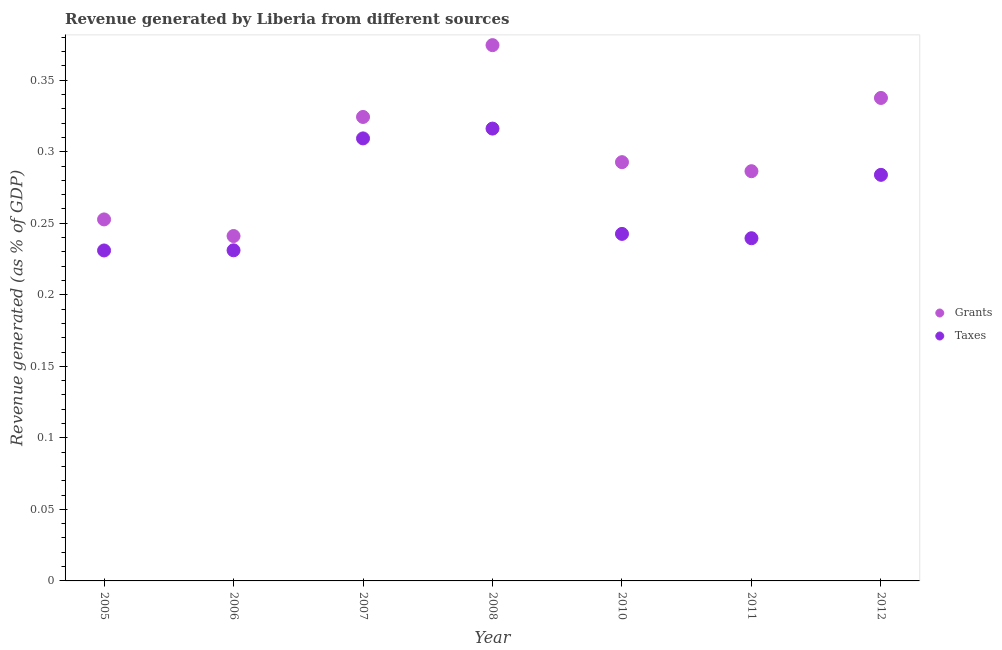What is the revenue generated by grants in 2006?
Give a very brief answer. 0.24. Across all years, what is the maximum revenue generated by grants?
Give a very brief answer. 0.37. Across all years, what is the minimum revenue generated by taxes?
Give a very brief answer. 0.23. In which year was the revenue generated by taxes maximum?
Your response must be concise. 2008. What is the total revenue generated by taxes in the graph?
Give a very brief answer. 1.85. What is the difference between the revenue generated by taxes in 2008 and that in 2011?
Make the answer very short. 0.08. What is the difference between the revenue generated by grants in 2005 and the revenue generated by taxes in 2008?
Offer a very short reply. -0.06. What is the average revenue generated by taxes per year?
Your answer should be compact. 0.26. In the year 2006, what is the difference between the revenue generated by taxes and revenue generated by grants?
Provide a succinct answer. -0.01. What is the ratio of the revenue generated by taxes in 2011 to that in 2012?
Your response must be concise. 0.84. Is the revenue generated by grants in 2005 less than that in 2010?
Keep it short and to the point. Yes. What is the difference between the highest and the second highest revenue generated by grants?
Your answer should be compact. 0.04. What is the difference between the highest and the lowest revenue generated by grants?
Offer a very short reply. 0.13. In how many years, is the revenue generated by grants greater than the average revenue generated by grants taken over all years?
Provide a short and direct response. 3. Does the revenue generated by taxes monotonically increase over the years?
Provide a short and direct response. No. Is the revenue generated by taxes strictly greater than the revenue generated by grants over the years?
Your answer should be very brief. No. Is the revenue generated by taxes strictly less than the revenue generated by grants over the years?
Offer a very short reply. Yes. How many dotlines are there?
Provide a succinct answer. 2. How many years are there in the graph?
Offer a terse response. 7. What is the difference between two consecutive major ticks on the Y-axis?
Your answer should be compact. 0.05. How are the legend labels stacked?
Keep it short and to the point. Vertical. What is the title of the graph?
Ensure brevity in your answer.  Revenue generated by Liberia from different sources. Does "Resident" appear as one of the legend labels in the graph?
Provide a short and direct response. No. What is the label or title of the Y-axis?
Offer a terse response. Revenue generated (as % of GDP). What is the Revenue generated (as % of GDP) in Grants in 2005?
Provide a succinct answer. 0.25. What is the Revenue generated (as % of GDP) in Taxes in 2005?
Ensure brevity in your answer.  0.23. What is the Revenue generated (as % of GDP) of Grants in 2006?
Your answer should be compact. 0.24. What is the Revenue generated (as % of GDP) in Taxes in 2006?
Ensure brevity in your answer.  0.23. What is the Revenue generated (as % of GDP) of Grants in 2007?
Offer a terse response. 0.32. What is the Revenue generated (as % of GDP) in Taxes in 2007?
Provide a succinct answer. 0.31. What is the Revenue generated (as % of GDP) of Grants in 2008?
Offer a terse response. 0.37. What is the Revenue generated (as % of GDP) of Taxes in 2008?
Provide a short and direct response. 0.32. What is the Revenue generated (as % of GDP) of Grants in 2010?
Make the answer very short. 0.29. What is the Revenue generated (as % of GDP) of Taxes in 2010?
Make the answer very short. 0.24. What is the Revenue generated (as % of GDP) of Grants in 2011?
Provide a short and direct response. 0.29. What is the Revenue generated (as % of GDP) in Taxes in 2011?
Your answer should be very brief. 0.24. What is the Revenue generated (as % of GDP) of Grants in 2012?
Offer a terse response. 0.34. What is the Revenue generated (as % of GDP) in Taxes in 2012?
Your answer should be very brief. 0.28. Across all years, what is the maximum Revenue generated (as % of GDP) in Grants?
Offer a terse response. 0.37. Across all years, what is the maximum Revenue generated (as % of GDP) of Taxes?
Your answer should be compact. 0.32. Across all years, what is the minimum Revenue generated (as % of GDP) of Grants?
Offer a terse response. 0.24. Across all years, what is the minimum Revenue generated (as % of GDP) in Taxes?
Offer a terse response. 0.23. What is the total Revenue generated (as % of GDP) in Grants in the graph?
Provide a succinct answer. 2.11. What is the total Revenue generated (as % of GDP) of Taxes in the graph?
Your response must be concise. 1.85. What is the difference between the Revenue generated (as % of GDP) of Grants in 2005 and that in 2006?
Offer a terse response. 0.01. What is the difference between the Revenue generated (as % of GDP) of Taxes in 2005 and that in 2006?
Make the answer very short. -0. What is the difference between the Revenue generated (as % of GDP) in Grants in 2005 and that in 2007?
Keep it short and to the point. -0.07. What is the difference between the Revenue generated (as % of GDP) of Taxes in 2005 and that in 2007?
Provide a succinct answer. -0.08. What is the difference between the Revenue generated (as % of GDP) in Grants in 2005 and that in 2008?
Ensure brevity in your answer.  -0.12. What is the difference between the Revenue generated (as % of GDP) in Taxes in 2005 and that in 2008?
Provide a succinct answer. -0.09. What is the difference between the Revenue generated (as % of GDP) in Grants in 2005 and that in 2010?
Make the answer very short. -0.04. What is the difference between the Revenue generated (as % of GDP) in Taxes in 2005 and that in 2010?
Your answer should be very brief. -0.01. What is the difference between the Revenue generated (as % of GDP) in Grants in 2005 and that in 2011?
Your answer should be compact. -0.03. What is the difference between the Revenue generated (as % of GDP) of Taxes in 2005 and that in 2011?
Make the answer very short. -0.01. What is the difference between the Revenue generated (as % of GDP) of Grants in 2005 and that in 2012?
Keep it short and to the point. -0.08. What is the difference between the Revenue generated (as % of GDP) of Taxes in 2005 and that in 2012?
Make the answer very short. -0.05. What is the difference between the Revenue generated (as % of GDP) of Grants in 2006 and that in 2007?
Provide a short and direct response. -0.08. What is the difference between the Revenue generated (as % of GDP) in Taxes in 2006 and that in 2007?
Offer a terse response. -0.08. What is the difference between the Revenue generated (as % of GDP) in Grants in 2006 and that in 2008?
Ensure brevity in your answer.  -0.13. What is the difference between the Revenue generated (as % of GDP) in Taxes in 2006 and that in 2008?
Make the answer very short. -0.09. What is the difference between the Revenue generated (as % of GDP) in Grants in 2006 and that in 2010?
Your response must be concise. -0.05. What is the difference between the Revenue generated (as % of GDP) of Taxes in 2006 and that in 2010?
Your answer should be compact. -0.01. What is the difference between the Revenue generated (as % of GDP) of Grants in 2006 and that in 2011?
Give a very brief answer. -0.05. What is the difference between the Revenue generated (as % of GDP) in Taxes in 2006 and that in 2011?
Provide a succinct answer. -0.01. What is the difference between the Revenue generated (as % of GDP) in Grants in 2006 and that in 2012?
Your answer should be very brief. -0.1. What is the difference between the Revenue generated (as % of GDP) in Taxes in 2006 and that in 2012?
Give a very brief answer. -0.05. What is the difference between the Revenue generated (as % of GDP) of Grants in 2007 and that in 2008?
Offer a very short reply. -0.05. What is the difference between the Revenue generated (as % of GDP) in Taxes in 2007 and that in 2008?
Give a very brief answer. -0.01. What is the difference between the Revenue generated (as % of GDP) of Grants in 2007 and that in 2010?
Keep it short and to the point. 0.03. What is the difference between the Revenue generated (as % of GDP) of Taxes in 2007 and that in 2010?
Offer a terse response. 0.07. What is the difference between the Revenue generated (as % of GDP) in Grants in 2007 and that in 2011?
Your answer should be compact. 0.04. What is the difference between the Revenue generated (as % of GDP) of Taxes in 2007 and that in 2011?
Provide a succinct answer. 0.07. What is the difference between the Revenue generated (as % of GDP) of Grants in 2007 and that in 2012?
Make the answer very short. -0.01. What is the difference between the Revenue generated (as % of GDP) in Taxes in 2007 and that in 2012?
Your answer should be very brief. 0.03. What is the difference between the Revenue generated (as % of GDP) in Grants in 2008 and that in 2010?
Offer a very short reply. 0.08. What is the difference between the Revenue generated (as % of GDP) of Taxes in 2008 and that in 2010?
Keep it short and to the point. 0.07. What is the difference between the Revenue generated (as % of GDP) of Grants in 2008 and that in 2011?
Offer a terse response. 0.09. What is the difference between the Revenue generated (as % of GDP) of Taxes in 2008 and that in 2011?
Keep it short and to the point. 0.08. What is the difference between the Revenue generated (as % of GDP) in Grants in 2008 and that in 2012?
Offer a very short reply. 0.04. What is the difference between the Revenue generated (as % of GDP) of Taxes in 2008 and that in 2012?
Keep it short and to the point. 0.03. What is the difference between the Revenue generated (as % of GDP) in Grants in 2010 and that in 2011?
Offer a very short reply. 0.01. What is the difference between the Revenue generated (as % of GDP) in Taxes in 2010 and that in 2011?
Offer a terse response. 0. What is the difference between the Revenue generated (as % of GDP) of Grants in 2010 and that in 2012?
Keep it short and to the point. -0.04. What is the difference between the Revenue generated (as % of GDP) in Taxes in 2010 and that in 2012?
Make the answer very short. -0.04. What is the difference between the Revenue generated (as % of GDP) of Grants in 2011 and that in 2012?
Keep it short and to the point. -0.05. What is the difference between the Revenue generated (as % of GDP) of Taxes in 2011 and that in 2012?
Offer a terse response. -0.04. What is the difference between the Revenue generated (as % of GDP) of Grants in 2005 and the Revenue generated (as % of GDP) of Taxes in 2006?
Offer a very short reply. 0.02. What is the difference between the Revenue generated (as % of GDP) of Grants in 2005 and the Revenue generated (as % of GDP) of Taxes in 2007?
Provide a short and direct response. -0.06. What is the difference between the Revenue generated (as % of GDP) in Grants in 2005 and the Revenue generated (as % of GDP) in Taxes in 2008?
Provide a short and direct response. -0.06. What is the difference between the Revenue generated (as % of GDP) in Grants in 2005 and the Revenue generated (as % of GDP) in Taxes in 2010?
Your response must be concise. 0.01. What is the difference between the Revenue generated (as % of GDP) in Grants in 2005 and the Revenue generated (as % of GDP) in Taxes in 2011?
Provide a short and direct response. 0.01. What is the difference between the Revenue generated (as % of GDP) of Grants in 2005 and the Revenue generated (as % of GDP) of Taxes in 2012?
Your answer should be very brief. -0.03. What is the difference between the Revenue generated (as % of GDP) in Grants in 2006 and the Revenue generated (as % of GDP) in Taxes in 2007?
Give a very brief answer. -0.07. What is the difference between the Revenue generated (as % of GDP) in Grants in 2006 and the Revenue generated (as % of GDP) in Taxes in 2008?
Offer a very short reply. -0.08. What is the difference between the Revenue generated (as % of GDP) in Grants in 2006 and the Revenue generated (as % of GDP) in Taxes in 2010?
Offer a very short reply. -0. What is the difference between the Revenue generated (as % of GDP) of Grants in 2006 and the Revenue generated (as % of GDP) of Taxes in 2011?
Your response must be concise. 0. What is the difference between the Revenue generated (as % of GDP) in Grants in 2006 and the Revenue generated (as % of GDP) in Taxes in 2012?
Your answer should be very brief. -0.04. What is the difference between the Revenue generated (as % of GDP) of Grants in 2007 and the Revenue generated (as % of GDP) of Taxes in 2008?
Give a very brief answer. 0.01. What is the difference between the Revenue generated (as % of GDP) of Grants in 2007 and the Revenue generated (as % of GDP) of Taxes in 2010?
Ensure brevity in your answer.  0.08. What is the difference between the Revenue generated (as % of GDP) of Grants in 2007 and the Revenue generated (as % of GDP) of Taxes in 2011?
Offer a very short reply. 0.08. What is the difference between the Revenue generated (as % of GDP) in Grants in 2007 and the Revenue generated (as % of GDP) in Taxes in 2012?
Make the answer very short. 0.04. What is the difference between the Revenue generated (as % of GDP) of Grants in 2008 and the Revenue generated (as % of GDP) of Taxes in 2010?
Provide a succinct answer. 0.13. What is the difference between the Revenue generated (as % of GDP) of Grants in 2008 and the Revenue generated (as % of GDP) of Taxes in 2011?
Your answer should be compact. 0.14. What is the difference between the Revenue generated (as % of GDP) in Grants in 2008 and the Revenue generated (as % of GDP) in Taxes in 2012?
Make the answer very short. 0.09. What is the difference between the Revenue generated (as % of GDP) in Grants in 2010 and the Revenue generated (as % of GDP) in Taxes in 2011?
Provide a short and direct response. 0.05. What is the difference between the Revenue generated (as % of GDP) in Grants in 2010 and the Revenue generated (as % of GDP) in Taxes in 2012?
Keep it short and to the point. 0.01. What is the difference between the Revenue generated (as % of GDP) in Grants in 2011 and the Revenue generated (as % of GDP) in Taxes in 2012?
Give a very brief answer. 0. What is the average Revenue generated (as % of GDP) in Grants per year?
Provide a short and direct response. 0.3. What is the average Revenue generated (as % of GDP) in Taxes per year?
Offer a terse response. 0.26. In the year 2005, what is the difference between the Revenue generated (as % of GDP) in Grants and Revenue generated (as % of GDP) in Taxes?
Make the answer very short. 0.02. In the year 2006, what is the difference between the Revenue generated (as % of GDP) in Grants and Revenue generated (as % of GDP) in Taxes?
Provide a succinct answer. 0.01. In the year 2007, what is the difference between the Revenue generated (as % of GDP) of Grants and Revenue generated (as % of GDP) of Taxes?
Offer a terse response. 0.01. In the year 2008, what is the difference between the Revenue generated (as % of GDP) in Grants and Revenue generated (as % of GDP) in Taxes?
Offer a very short reply. 0.06. In the year 2010, what is the difference between the Revenue generated (as % of GDP) of Grants and Revenue generated (as % of GDP) of Taxes?
Your answer should be compact. 0.05. In the year 2011, what is the difference between the Revenue generated (as % of GDP) in Grants and Revenue generated (as % of GDP) in Taxes?
Your response must be concise. 0.05. In the year 2012, what is the difference between the Revenue generated (as % of GDP) of Grants and Revenue generated (as % of GDP) of Taxes?
Give a very brief answer. 0.05. What is the ratio of the Revenue generated (as % of GDP) of Grants in 2005 to that in 2006?
Your answer should be compact. 1.05. What is the ratio of the Revenue generated (as % of GDP) in Taxes in 2005 to that in 2006?
Your response must be concise. 1. What is the ratio of the Revenue generated (as % of GDP) in Grants in 2005 to that in 2007?
Ensure brevity in your answer.  0.78. What is the ratio of the Revenue generated (as % of GDP) in Taxes in 2005 to that in 2007?
Your response must be concise. 0.75. What is the ratio of the Revenue generated (as % of GDP) of Grants in 2005 to that in 2008?
Keep it short and to the point. 0.67. What is the ratio of the Revenue generated (as % of GDP) in Taxes in 2005 to that in 2008?
Keep it short and to the point. 0.73. What is the ratio of the Revenue generated (as % of GDP) of Grants in 2005 to that in 2010?
Your response must be concise. 0.86. What is the ratio of the Revenue generated (as % of GDP) in Taxes in 2005 to that in 2010?
Keep it short and to the point. 0.95. What is the ratio of the Revenue generated (as % of GDP) of Grants in 2005 to that in 2011?
Make the answer very short. 0.88. What is the ratio of the Revenue generated (as % of GDP) of Grants in 2005 to that in 2012?
Make the answer very short. 0.75. What is the ratio of the Revenue generated (as % of GDP) of Taxes in 2005 to that in 2012?
Ensure brevity in your answer.  0.81. What is the ratio of the Revenue generated (as % of GDP) in Grants in 2006 to that in 2007?
Provide a short and direct response. 0.74. What is the ratio of the Revenue generated (as % of GDP) in Taxes in 2006 to that in 2007?
Provide a succinct answer. 0.75. What is the ratio of the Revenue generated (as % of GDP) in Grants in 2006 to that in 2008?
Your answer should be very brief. 0.64. What is the ratio of the Revenue generated (as % of GDP) in Taxes in 2006 to that in 2008?
Ensure brevity in your answer.  0.73. What is the ratio of the Revenue generated (as % of GDP) in Grants in 2006 to that in 2010?
Offer a terse response. 0.82. What is the ratio of the Revenue generated (as % of GDP) in Taxes in 2006 to that in 2010?
Offer a very short reply. 0.95. What is the ratio of the Revenue generated (as % of GDP) in Grants in 2006 to that in 2011?
Make the answer very short. 0.84. What is the ratio of the Revenue generated (as % of GDP) of Taxes in 2006 to that in 2011?
Make the answer very short. 0.96. What is the ratio of the Revenue generated (as % of GDP) in Grants in 2006 to that in 2012?
Offer a terse response. 0.71. What is the ratio of the Revenue generated (as % of GDP) in Taxes in 2006 to that in 2012?
Your response must be concise. 0.81. What is the ratio of the Revenue generated (as % of GDP) of Grants in 2007 to that in 2008?
Your answer should be compact. 0.87. What is the ratio of the Revenue generated (as % of GDP) of Taxes in 2007 to that in 2008?
Provide a short and direct response. 0.98. What is the ratio of the Revenue generated (as % of GDP) in Grants in 2007 to that in 2010?
Your answer should be very brief. 1.11. What is the ratio of the Revenue generated (as % of GDP) of Taxes in 2007 to that in 2010?
Offer a very short reply. 1.28. What is the ratio of the Revenue generated (as % of GDP) of Grants in 2007 to that in 2011?
Give a very brief answer. 1.13. What is the ratio of the Revenue generated (as % of GDP) in Taxes in 2007 to that in 2011?
Make the answer very short. 1.29. What is the ratio of the Revenue generated (as % of GDP) of Grants in 2007 to that in 2012?
Keep it short and to the point. 0.96. What is the ratio of the Revenue generated (as % of GDP) of Taxes in 2007 to that in 2012?
Provide a short and direct response. 1.09. What is the ratio of the Revenue generated (as % of GDP) of Grants in 2008 to that in 2010?
Ensure brevity in your answer.  1.28. What is the ratio of the Revenue generated (as % of GDP) in Taxes in 2008 to that in 2010?
Keep it short and to the point. 1.3. What is the ratio of the Revenue generated (as % of GDP) of Grants in 2008 to that in 2011?
Provide a succinct answer. 1.31. What is the ratio of the Revenue generated (as % of GDP) in Taxes in 2008 to that in 2011?
Your response must be concise. 1.32. What is the ratio of the Revenue generated (as % of GDP) in Grants in 2008 to that in 2012?
Keep it short and to the point. 1.11. What is the ratio of the Revenue generated (as % of GDP) in Taxes in 2008 to that in 2012?
Keep it short and to the point. 1.11. What is the ratio of the Revenue generated (as % of GDP) in Grants in 2010 to that in 2011?
Offer a very short reply. 1.02. What is the ratio of the Revenue generated (as % of GDP) of Taxes in 2010 to that in 2011?
Offer a terse response. 1.01. What is the ratio of the Revenue generated (as % of GDP) of Grants in 2010 to that in 2012?
Keep it short and to the point. 0.87. What is the ratio of the Revenue generated (as % of GDP) in Taxes in 2010 to that in 2012?
Offer a terse response. 0.85. What is the ratio of the Revenue generated (as % of GDP) of Grants in 2011 to that in 2012?
Provide a succinct answer. 0.85. What is the ratio of the Revenue generated (as % of GDP) of Taxes in 2011 to that in 2012?
Ensure brevity in your answer.  0.84. What is the difference between the highest and the second highest Revenue generated (as % of GDP) in Grants?
Keep it short and to the point. 0.04. What is the difference between the highest and the second highest Revenue generated (as % of GDP) of Taxes?
Give a very brief answer. 0.01. What is the difference between the highest and the lowest Revenue generated (as % of GDP) of Grants?
Provide a succinct answer. 0.13. What is the difference between the highest and the lowest Revenue generated (as % of GDP) of Taxes?
Make the answer very short. 0.09. 